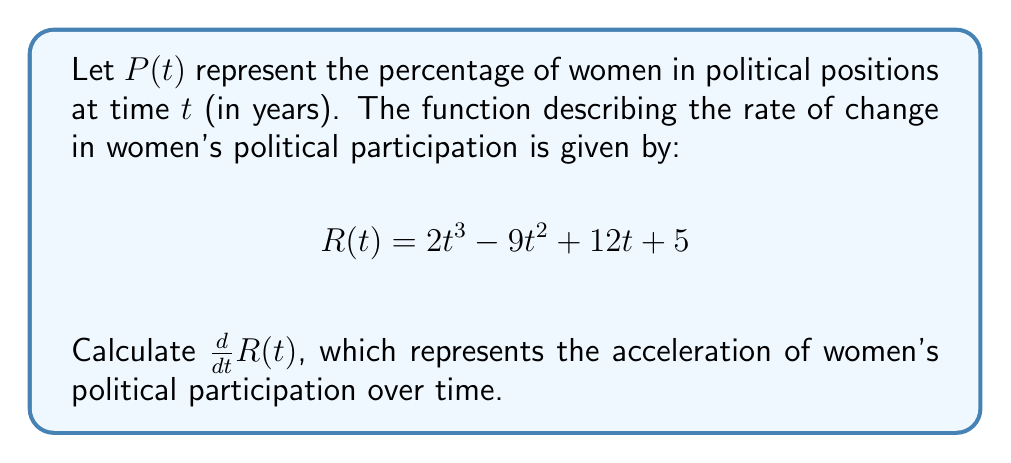Could you help me with this problem? To find the derivative of $R(t)$, we need to apply the power rule and the constant rule of differentiation:

1) For the term $2t^3$:
   The derivative of $t^3$ is $3t^2$, so $\frac{d}{dt}(2t^3) = 2 \cdot 3t^2 = 6t^2$

2) For the term $-9t^2$:
   The derivative of $t^2$ is $2t$, so $\frac{d}{dt}(-9t^2) = -9 \cdot 2t = -18t$

3) For the term $12t$:
   The derivative of $t$ is $1$, so $\frac{d}{dt}(12t) = 12$

4) For the constant term $5$:
   The derivative of a constant is $0$, so $\frac{d}{dt}(5) = 0$

Now, we sum up all these terms:

$$\frac{d}{dt}R(t) = 6t^2 - 18t + 12 + 0 = 6t^2 - 18t + 12$$

This result represents the acceleration of women's political participation over time.
Answer: $\frac{d}{dt}R(t) = 6t^2 - 18t + 12$ 